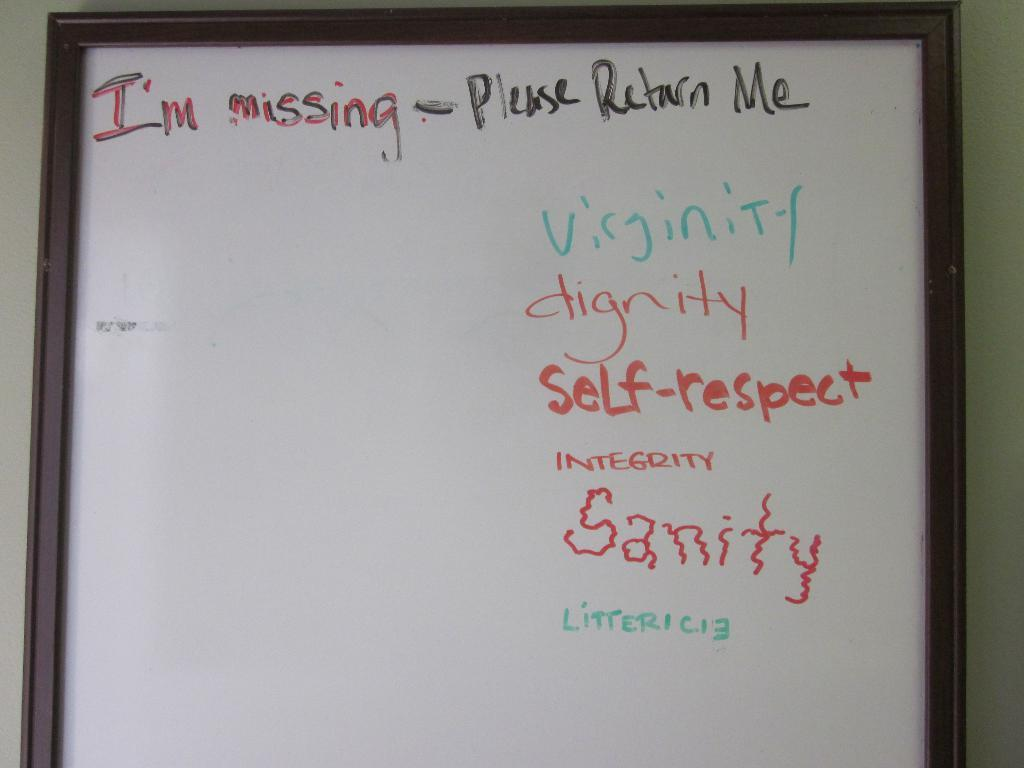What is present on the frame in the image? There is text on a frame in the image. Where is the frame located in the image? The frame is hanging on a wall. What type of wool is used to make the calculator in the image? There is no calculator present in the image, and therefore no wool is used to make it. 